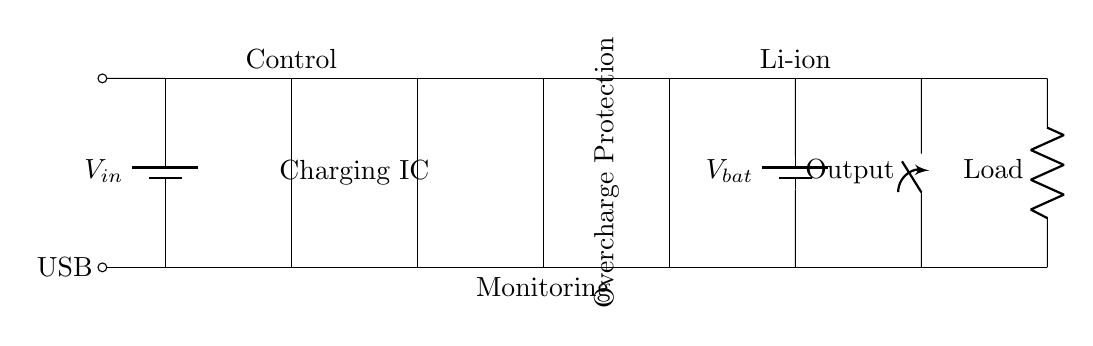What power source is used in this circuit? The circuit diagram shows a USB power source labeled as V_in, indicating that the input voltage comes from a USB connection.
Answer: USB What component is responsible for charging the battery? The Charging IC, which is illustrated as a rectangle in the circuit diagram, is tasked with managing the battery charging process.
Answer: Charging IC How does the circuit prevent overcharging? The Overcharge Protection block indicated in the circuit diagram is designed to monitor and regulate the charging process to prevent overcharging of the battery.
Answer: Overcharge Protection What type of battery is used in this circuit? The battery component is labeled as V_bat, which typically signifies a Lithium-ion (Li-ion) battery in portable charging applications.
Answer: Li-ion What is the role of the control section in the circuit? The control section, labeled above the Charging IC, denotes components that manage the operation of the Charging IC and ensure proper functioning of the charging process.
Answer: Control What happens if the load is too high for the battery? If the load exceeds the battery's capacity, the circuit may fail to supply sufficient power, leading to a potential shutdown or activation of protection mechanisms; however, such details are inferred rather than depicted.
Answer: Yes 